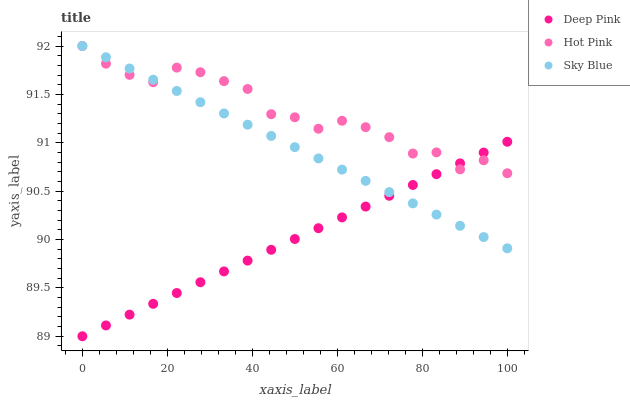Does Deep Pink have the minimum area under the curve?
Answer yes or no. Yes. Does Hot Pink have the maximum area under the curve?
Answer yes or no. Yes. Does Hot Pink have the minimum area under the curve?
Answer yes or no. No. Does Deep Pink have the maximum area under the curve?
Answer yes or no. No. Is Deep Pink the smoothest?
Answer yes or no. Yes. Is Hot Pink the roughest?
Answer yes or no. Yes. Is Hot Pink the smoothest?
Answer yes or no. No. Is Deep Pink the roughest?
Answer yes or no. No. Does Deep Pink have the lowest value?
Answer yes or no. Yes. Does Hot Pink have the lowest value?
Answer yes or no. No. Does Hot Pink have the highest value?
Answer yes or no. Yes. Does Deep Pink have the highest value?
Answer yes or no. No. Does Deep Pink intersect Hot Pink?
Answer yes or no. Yes. Is Deep Pink less than Hot Pink?
Answer yes or no. No. Is Deep Pink greater than Hot Pink?
Answer yes or no. No. 